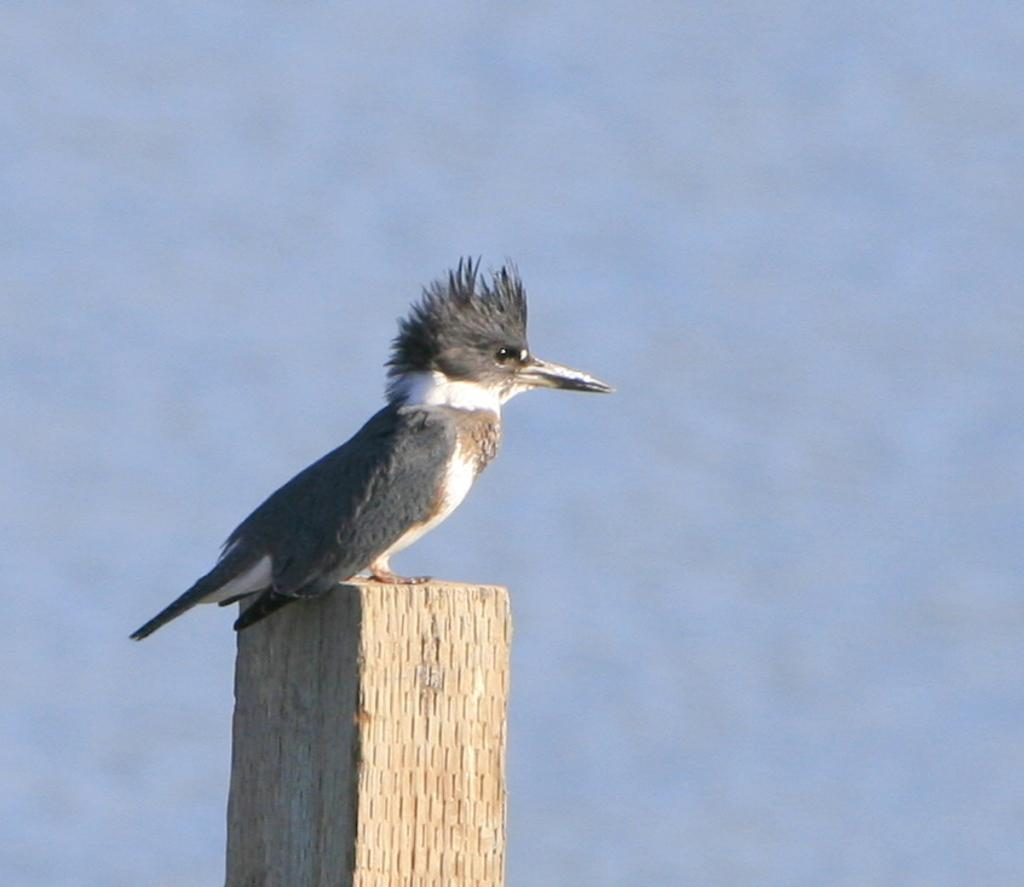What type of animal can be seen in the image? There is a bird in the image. What color is the bird? The bird is grey in color. What is visible in the background of the image? There is sky visible in the image. What type of desk can be seen in the image? There is no desk present in the image; it features a bird and sky. What force is being applied to the bird in the image? There is no force being applied to the bird in the image; it is simply perched or flying. 